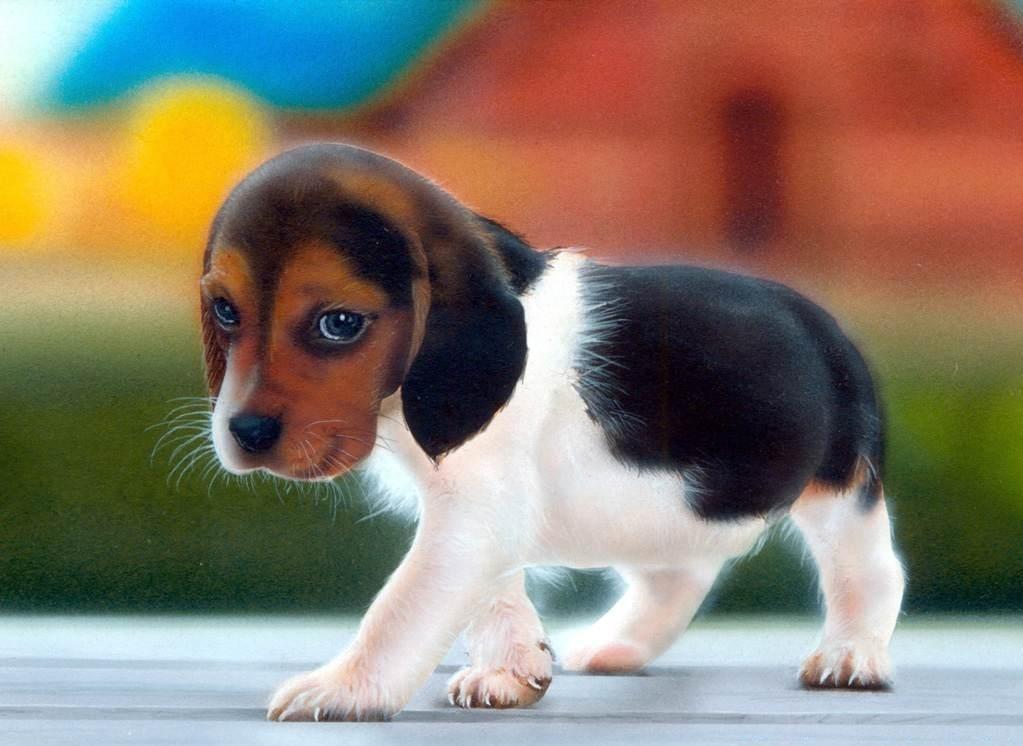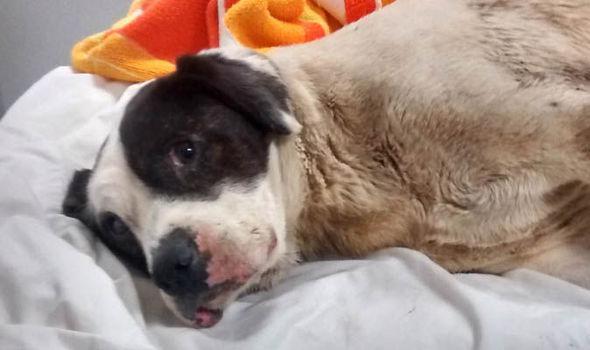The first image is the image on the left, the second image is the image on the right. Considering the images on both sides, is "The image on the right shows at least one beagle puppy held by a human hand." valid? Answer yes or no. No. The first image is the image on the left, the second image is the image on the right. Assess this claim about the two images: "there is a beagle puppy lying belly down in the image to the left". Correct or not? Answer yes or no. No. 